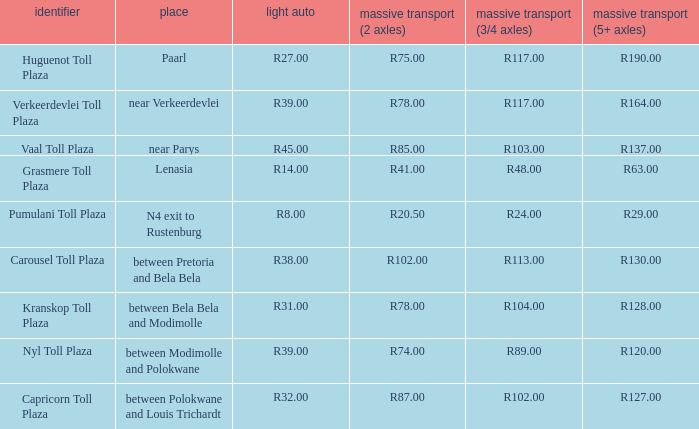What is the toll for light vehicles at the plaza where the toll for heavy vehicles with 2 axles is r87.00? R32.00. 